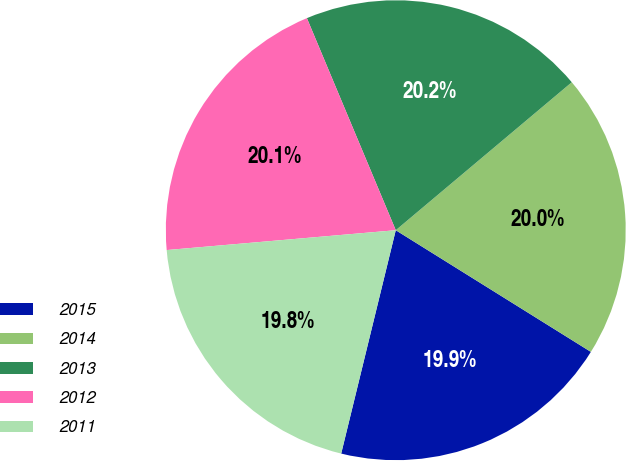Convert chart. <chart><loc_0><loc_0><loc_500><loc_500><pie_chart><fcel>2015<fcel>2014<fcel>2013<fcel>2012<fcel>2011<nl><fcel>19.94%<fcel>20.0%<fcel>20.19%<fcel>20.06%<fcel>19.81%<nl></chart> 